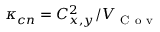<formula> <loc_0><loc_0><loc_500><loc_500>\kappa _ { c n } = C _ { x , y } ^ { 2 } / V _ { C o v }</formula> 